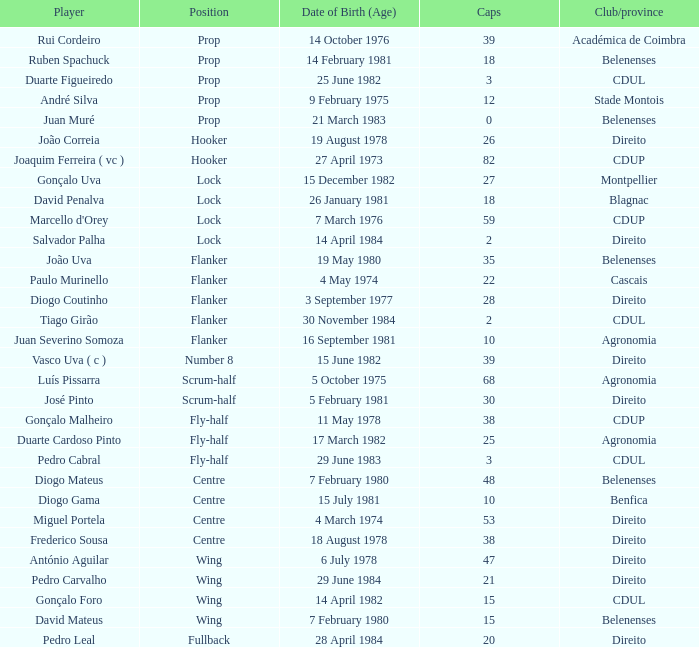How many caps possess a date of birth (age) corresponding to july 15, 1981? 1.0. 